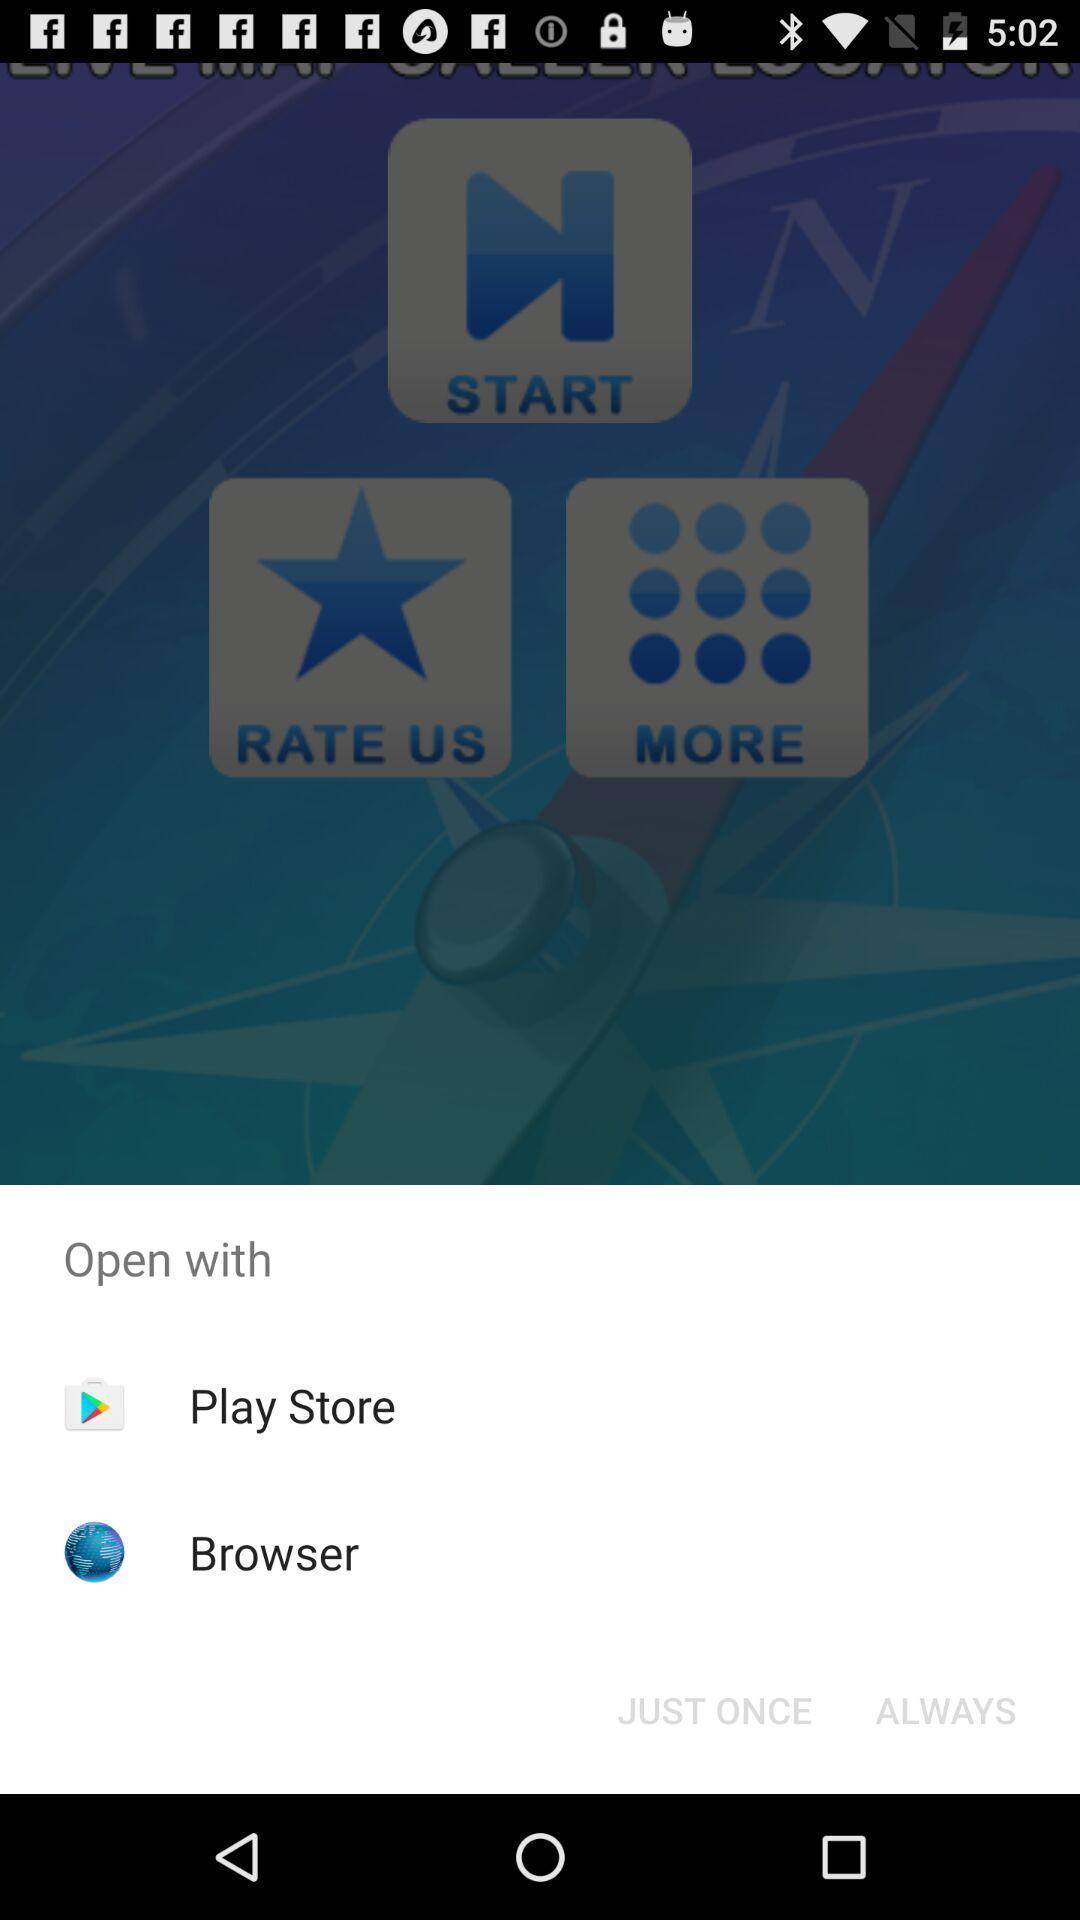Please provide a description for this image. Push up page showing app preference to open. 